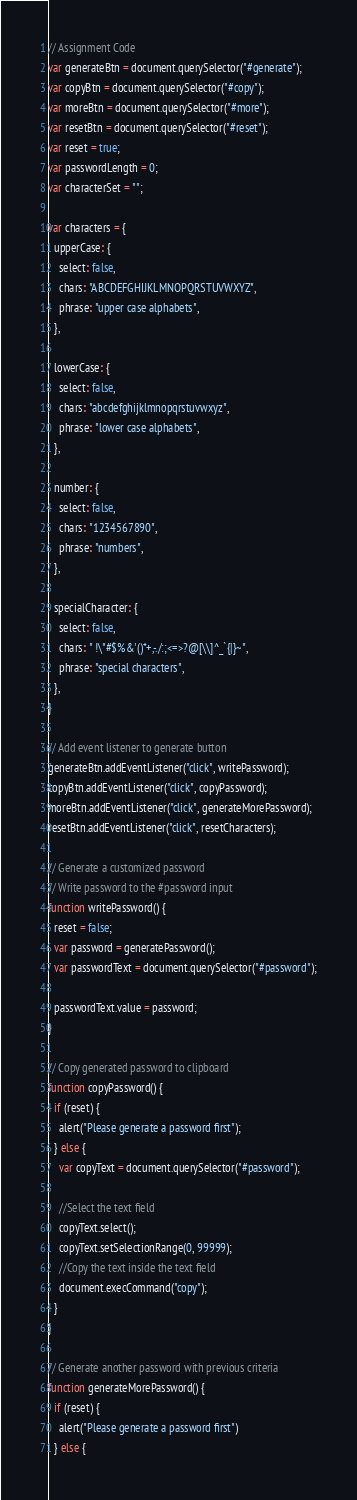Convert code to text. <code><loc_0><loc_0><loc_500><loc_500><_JavaScript_>// Assignment Code
var generateBtn = document.querySelector("#generate");
var copyBtn = document.querySelector("#copy");
var moreBtn = document.querySelector("#more");
var resetBtn = document.querySelector("#reset");
var reset = true;
var passwordLength = 0;
var characterSet = "";

var characters = {
  upperCase: {
    select: false,
    chars: "ABCDEFGHIJKLMNOPQRSTUVWXYZ",
    phrase: "upper case alphabets",
  },

  lowerCase: {
    select: false,
    chars: "abcdefghijklmnopqrstuvwxyz",
    phrase: "lower case alphabets",
  },

  number: {
    select: false,
    chars: "1234567890",
    phrase: "numbers",
  },

  specialCharacter: {
    select: false,
    chars: " !\"#$%&'()*+,-./:;<=>?@[\\]^_`{|}~",
    phrase: "special characters",
  },
}

// Add event listener to generate button
generateBtn.addEventListener("click", writePassword);
copyBtn.addEventListener("click", copyPassword);
moreBtn.addEventListener("click", generateMorePassword);
resetBtn.addEventListener("click", resetCharacters);

// Generate a customized password
// Write password to the #password input
function writePassword() {
  reset = false;
  var password = generatePassword();
  var passwordText = document.querySelector("#password");

  passwordText.value = password;
}

// Copy generated password to clipboard
function copyPassword() {
  if (reset) {
    alert("Please generate a password first");
  } else {
    var copyText = document.querySelector("#password");

    //Select the text field
    copyText.select();
    copyText.setSelectionRange(0, 99999);
    //Copy the text inside the text field
    document.execCommand("copy");
  }
}

// Generate another password with previous criteria
function generateMorePassword() {
  if (reset) {
    alert("Please generate a password first")
  } else {</code> 